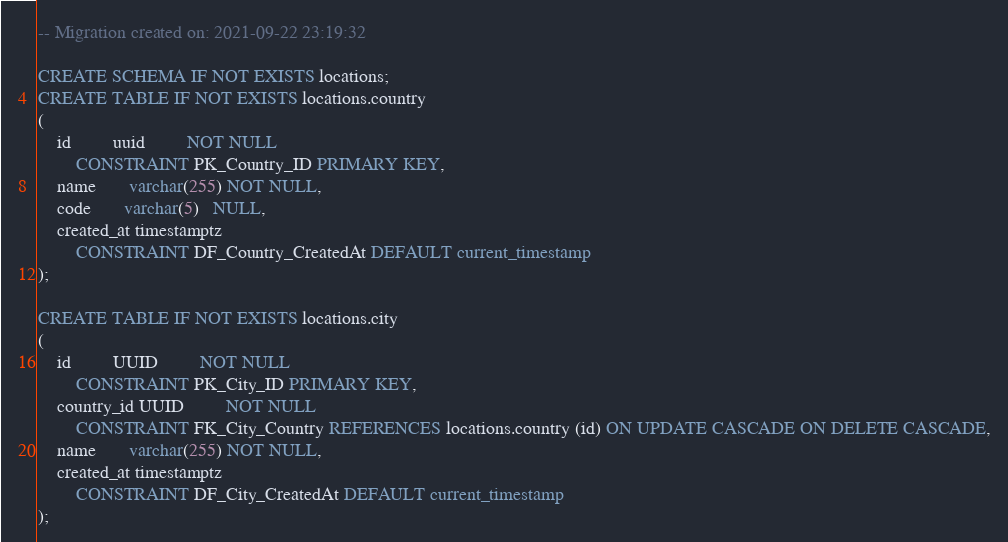<code> <loc_0><loc_0><loc_500><loc_500><_SQL_>-- Migration created on: 2021-09-22 23:19:32

CREATE SCHEMA IF NOT EXISTS locations;
CREATE TABLE IF NOT EXISTS locations.country
(
    id         uuid         NOT NULL
        CONSTRAINT PK_Country_ID PRIMARY KEY,
    name       varchar(255) NOT NULL,
    code       varchar(5)   NULL,
    created_at timestamptz
        CONSTRAINT DF_Country_CreatedAt DEFAULT current_timestamp
);

CREATE TABLE IF NOT EXISTS locations.city
(
    id         UUID         NOT NULL
        CONSTRAINT PK_City_ID PRIMARY KEY,
    country_id UUID         NOT NULL
        CONSTRAINT FK_City_Country REFERENCES locations.country (id) ON UPDATE CASCADE ON DELETE CASCADE,
    name       varchar(255) NOT NULL,
    created_at timestamptz
        CONSTRAINT DF_City_CreatedAt DEFAULT current_timestamp
);</code> 